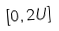Convert formula to latex. <formula><loc_0><loc_0><loc_500><loc_500>[ 0 , 2 U ]</formula> 